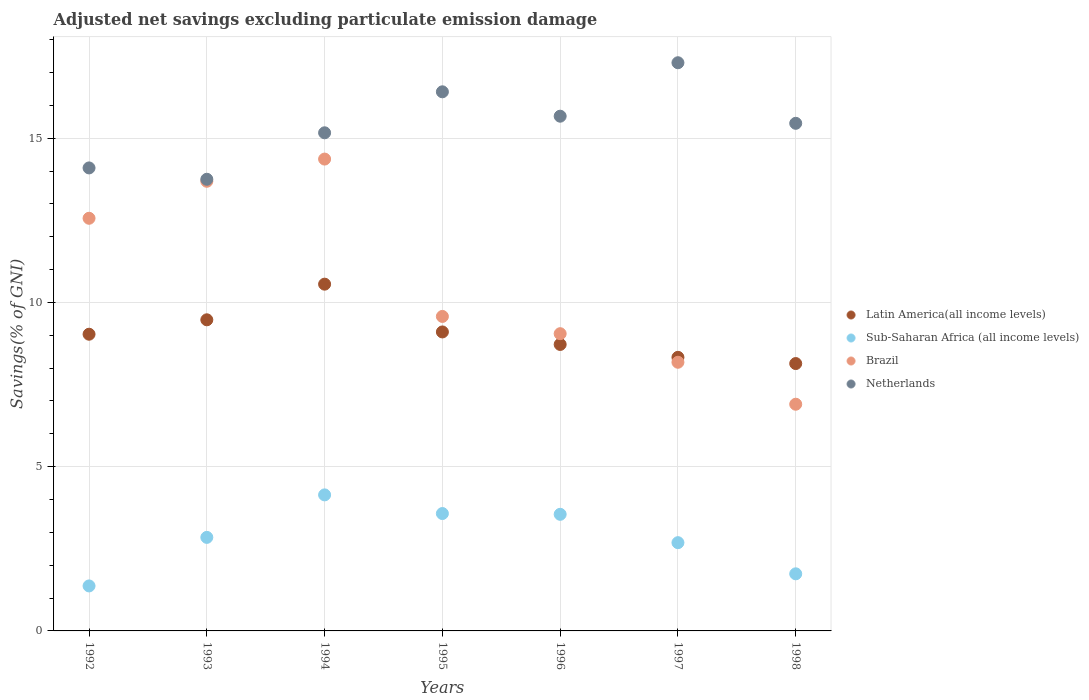How many different coloured dotlines are there?
Give a very brief answer. 4. Is the number of dotlines equal to the number of legend labels?
Provide a succinct answer. Yes. What is the adjusted net savings in Netherlands in 1998?
Your response must be concise. 15.45. Across all years, what is the maximum adjusted net savings in Sub-Saharan Africa (all income levels)?
Make the answer very short. 4.14. Across all years, what is the minimum adjusted net savings in Netherlands?
Your response must be concise. 13.75. In which year was the adjusted net savings in Netherlands minimum?
Make the answer very short. 1993. What is the total adjusted net savings in Sub-Saharan Africa (all income levels) in the graph?
Keep it short and to the point. 19.91. What is the difference between the adjusted net savings in Brazil in 1996 and that in 1997?
Provide a succinct answer. 0.87. What is the difference between the adjusted net savings in Latin America(all income levels) in 1994 and the adjusted net savings in Sub-Saharan Africa (all income levels) in 1996?
Provide a short and direct response. 7.01. What is the average adjusted net savings in Sub-Saharan Africa (all income levels) per year?
Provide a short and direct response. 2.84. In the year 1995, what is the difference between the adjusted net savings in Brazil and adjusted net savings in Netherlands?
Your response must be concise. -6.84. What is the ratio of the adjusted net savings in Brazil in 1993 to that in 1998?
Keep it short and to the point. 1.98. Is the difference between the adjusted net savings in Brazil in 1992 and 1993 greater than the difference between the adjusted net savings in Netherlands in 1992 and 1993?
Offer a very short reply. No. What is the difference between the highest and the second highest adjusted net savings in Sub-Saharan Africa (all income levels)?
Give a very brief answer. 0.57. What is the difference between the highest and the lowest adjusted net savings in Netherlands?
Offer a terse response. 3.55. In how many years, is the adjusted net savings in Latin America(all income levels) greater than the average adjusted net savings in Latin America(all income levels) taken over all years?
Ensure brevity in your answer.  3. Is the sum of the adjusted net savings in Netherlands in 1994 and 1998 greater than the maximum adjusted net savings in Latin America(all income levels) across all years?
Provide a short and direct response. Yes. Is it the case that in every year, the sum of the adjusted net savings in Latin America(all income levels) and adjusted net savings in Sub-Saharan Africa (all income levels)  is greater than the sum of adjusted net savings in Netherlands and adjusted net savings in Brazil?
Make the answer very short. No. Is the adjusted net savings in Netherlands strictly greater than the adjusted net savings in Brazil over the years?
Your answer should be compact. Yes. Is the adjusted net savings in Brazil strictly less than the adjusted net savings in Latin America(all income levels) over the years?
Your answer should be very brief. No. What is the difference between two consecutive major ticks on the Y-axis?
Make the answer very short. 5. Are the values on the major ticks of Y-axis written in scientific E-notation?
Your answer should be compact. No. Does the graph contain any zero values?
Make the answer very short. No. Where does the legend appear in the graph?
Provide a succinct answer. Center right. How are the legend labels stacked?
Your response must be concise. Vertical. What is the title of the graph?
Make the answer very short. Adjusted net savings excluding particulate emission damage. What is the label or title of the X-axis?
Keep it short and to the point. Years. What is the label or title of the Y-axis?
Offer a very short reply. Savings(% of GNI). What is the Savings(% of GNI) of Latin America(all income levels) in 1992?
Provide a succinct answer. 9.03. What is the Savings(% of GNI) in Sub-Saharan Africa (all income levels) in 1992?
Offer a terse response. 1.37. What is the Savings(% of GNI) in Brazil in 1992?
Your answer should be very brief. 12.56. What is the Savings(% of GNI) in Netherlands in 1992?
Your response must be concise. 14.09. What is the Savings(% of GNI) of Latin America(all income levels) in 1993?
Ensure brevity in your answer.  9.47. What is the Savings(% of GNI) in Sub-Saharan Africa (all income levels) in 1993?
Offer a terse response. 2.85. What is the Savings(% of GNI) in Brazil in 1993?
Provide a short and direct response. 13.69. What is the Savings(% of GNI) in Netherlands in 1993?
Your answer should be very brief. 13.75. What is the Savings(% of GNI) in Latin America(all income levels) in 1994?
Your answer should be compact. 10.56. What is the Savings(% of GNI) in Sub-Saharan Africa (all income levels) in 1994?
Keep it short and to the point. 4.14. What is the Savings(% of GNI) in Brazil in 1994?
Your response must be concise. 14.36. What is the Savings(% of GNI) in Netherlands in 1994?
Your answer should be compact. 15.16. What is the Savings(% of GNI) of Latin America(all income levels) in 1995?
Your answer should be compact. 9.1. What is the Savings(% of GNI) of Sub-Saharan Africa (all income levels) in 1995?
Provide a short and direct response. 3.57. What is the Savings(% of GNI) of Brazil in 1995?
Offer a very short reply. 9.57. What is the Savings(% of GNI) of Netherlands in 1995?
Offer a very short reply. 16.41. What is the Savings(% of GNI) in Latin America(all income levels) in 1996?
Offer a very short reply. 8.72. What is the Savings(% of GNI) in Sub-Saharan Africa (all income levels) in 1996?
Your answer should be compact. 3.55. What is the Savings(% of GNI) of Brazil in 1996?
Provide a short and direct response. 9.05. What is the Savings(% of GNI) of Netherlands in 1996?
Give a very brief answer. 15.67. What is the Savings(% of GNI) of Latin America(all income levels) in 1997?
Offer a terse response. 8.33. What is the Savings(% of GNI) of Sub-Saharan Africa (all income levels) in 1997?
Ensure brevity in your answer.  2.69. What is the Savings(% of GNI) in Brazil in 1997?
Your answer should be compact. 8.18. What is the Savings(% of GNI) in Netherlands in 1997?
Your answer should be compact. 17.3. What is the Savings(% of GNI) of Latin America(all income levels) in 1998?
Offer a very short reply. 8.14. What is the Savings(% of GNI) in Sub-Saharan Africa (all income levels) in 1998?
Keep it short and to the point. 1.74. What is the Savings(% of GNI) of Brazil in 1998?
Your response must be concise. 6.9. What is the Savings(% of GNI) of Netherlands in 1998?
Make the answer very short. 15.45. Across all years, what is the maximum Savings(% of GNI) of Latin America(all income levels)?
Your response must be concise. 10.56. Across all years, what is the maximum Savings(% of GNI) in Sub-Saharan Africa (all income levels)?
Keep it short and to the point. 4.14. Across all years, what is the maximum Savings(% of GNI) in Brazil?
Give a very brief answer. 14.36. Across all years, what is the maximum Savings(% of GNI) of Netherlands?
Offer a very short reply. 17.3. Across all years, what is the minimum Savings(% of GNI) of Latin America(all income levels)?
Your answer should be very brief. 8.14. Across all years, what is the minimum Savings(% of GNI) in Sub-Saharan Africa (all income levels)?
Provide a short and direct response. 1.37. Across all years, what is the minimum Savings(% of GNI) in Brazil?
Ensure brevity in your answer.  6.9. Across all years, what is the minimum Savings(% of GNI) of Netherlands?
Your response must be concise. 13.75. What is the total Savings(% of GNI) of Latin America(all income levels) in the graph?
Provide a short and direct response. 63.35. What is the total Savings(% of GNI) in Sub-Saharan Africa (all income levels) in the graph?
Ensure brevity in your answer.  19.91. What is the total Savings(% of GNI) in Brazil in the graph?
Provide a short and direct response. 74.31. What is the total Savings(% of GNI) in Netherlands in the graph?
Your response must be concise. 107.84. What is the difference between the Savings(% of GNI) of Latin America(all income levels) in 1992 and that in 1993?
Provide a short and direct response. -0.44. What is the difference between the Savings(% of GNI) of Sub-Saharan Africa (all income levels) in 1992 and that in 1993?
Your answer should be compact. -1.48. What is the difference between the Savings(% of GNI) in Brazil in 1992 and that in 1993?
Your response must be concise. -1.13. What is the difference between the Savings(% of GNI) of Netherlands in 1992 and that in 1993?
Keep it short and to the point. 0.35. What is the difference between the Savings(% of GNI) in Latin America(all income levels) in 1992 and that in 1994?
Offer a terse response. -1.52. What is the difference between the Savings(% of GNI) in Sub-Saharan Africa (all income levels) in 1992 and that in 1994?
Your answer should be very brief. -2.77. What is the difference between the Savings(% of GNI) of Brazil in 1992 and that in 1994?
Keep it short and to the point. -1.8. What is the difference between the Savings(% of GNI) of Netherlands in 1992 and that in 1994?
Your response must be concise. -1.07. What is the difference between the Savings(% of GNI) of Latin America(all income levels) in 1992 and that in 1995?
Give a very brief answer. -0.07. What is the difference between the Savings(% of GNI) in Sub-Saharan Africa (all income levels) in 1992 and that in 1995?
Keep it short and to the point. -2.2. What is the difference between the Savings(% of GNI) in Brazil in 1992 and that in 1995?
Provide a short and direct response. 2.99. What is the difference between the Savings(% of GNI) of Netherlands in 1992 and that in 1995?
Ensure brevity in your answer.  -2.32. What is the difference between the Savings(% of GNI) in Latin America(all income levels) in 1992 and that in 1996?
Your answer should be very brief. 0.31. What is the difference between the Savings(% of GNI) of Sub-Saharan Africa (all income levels) in 1992 and that in 1996?
Provide a succinct answer. -2.18. What is the difference between the Savings(% of GNI) in Brazil in 1992 and that in 1996?
Your answer should be very brief. 3.51. What is the difference between the Savings(% of GNI) of Netherlands in 1992 and that in 1996?
Provide a short and direct response. -1.57. What is the difference between the Savings(% of GNI) in Latin America(all income levels) in 1992 and that in 1997?
Offer a very short reply. 0.7. What is the difference between the Savings(% of GNI) of Sub-Saharan Africa (all income levels) in 1992 and that in 1997?
Ensure brevity in your answer.  -1.32. What is the difference between the Savings(% of GNI) in Brazil in 1992 and that in 1997?
Offer a terse response. 4.38. What is the difference between the Savings(% of GNI) in Netherlands in 1992 and that in 1997?
Offer a terse response. -3.2. What is the difference between the Savings(% of GNI) of Latin America(all income levels) in 1992 and that in 1998?
Make the answer very short. 0.89. What is the difference between the Savings(% of GNI) of Sub-Saharan Africa (all income levels) in 1992 and that in 1998?
Your response must be concise. -0.37. What is the difference between the Savings(% of GNI) in Brazil in 1992 and that in 1998?
Give a very brief answer. 5.66. What is the difference between the Savings(% of GNI) in Netherlands in 1992 and that in 1998?
Offer a terse response. -1.36. What is the difference between the Savings(% of GNI) of Latin America(all income levels) in 1993 and that in 1994?
Your answer should be very brief. -1.08. What is the difference between the Savings(% of GNI) in Sub-Saharan Africa (all income levels) in 1993 and that in 1994?
Your response must be concise. -1.29. What is the difference between the Savings(% of GNI) in Brazil in 1993 and that in 1994?
Your answer should be compact. -0.68. What is the difference between the Savings(% of GNI) in Netherlands in 1993 and that in 1994?
Give a very brief answer. -1.41. What is the difference between the Savings(% of GNI) of Latin America(all income levels) in 1993 and that in 1995?
Provide a short and direct response. 0.37. What is the difference between the Savings(% of GNI) of Sub-Saharan Africa (all income levels) in 1993 and that in 1995?
Keep it short and to the point. -0.73. What is the difference between the Savings(% of GNI) in Brazil in 1993 and that in 1995?
Offer a terse response. 4.11. What is the difference between the Savings(% of GNI) of Netherlands in 1993 and that in 1995?
Your response must be concise. -2.66. What is the difference between the Savings(% of GNI) of Latin America(all income levels) in 1993 and that in 1996?
Make the answer very short. 0.75. What is the difference between the Savings(% of GNI) of Sub-Saharan Africa (all income levels) in 1993 and that in 1996?
Make the answer very short. -0.7. What is the difference between the Savings(% of GNI) of Brazil in 1993 and that in 1996?
Your answer should be very brief. 4.64. What is the difference between the Savings(% of GNI) of Netherlands in 1993 and that in 1996?
Provide a succinct answer. -1.92. What is the difference between the Savings(% of GNI) of Latin America(all income levels) in 1993 and that in 1997?
Offer a terse response. 1.14. What is the difference between the Savings(% of GNI) in Sub-Saharan Africa (all income levels) in 1993 and that in 1997?
Offer a terse response. 0.16. What is the difference between the Savings(% of GNI) in Brazil in 1993 and that in 1997?
Give a very brief answer. 5.51. What is the difference between the Savings(% of GNI) of Netherlands in 1993 and that in 1997?
Your answer should be very brief. -3.55. What is the difference between the Savings(% of GNI) of Latin America(all income levels) in 1993 and that in 1998?
Keep it short and to the point. 1.33. What is the difference between the Savings(% of GNI) of Sub-Saharan Africa (all income levels) in 1993 and that in 1998?
Give a very brief answer. 1.11. What is the difference between the Savings(% of GNI) in Brazil in 1993 and that in 1998?
Keep it short and to the point. 6.79. What is the difference between the Savings(% of GNI) of Netherlands in 1993 and that in 1998?
Your answer should be very brief. -1.7. What is the difference between the Savings(% of GNI) of Latin America(all income levels) in 1994 and that in 1995?
Provide a short and direct response. 1.45. What is the difference between the Savings(% of GNI) in Sub-Saharan Africa (all income levels) in 1994 and that in 1995?
Provide a short and direct response. 0.57. What is the difference between the Savings(% of GNI) of Brazil in 1994 and that in 1995?
Provide a succinct answer. 4.79. What is the difference between the Savings(% of GNI) of Netherlands in 1994 and that in 1995?
Keep it short and to the point. -1.25. What is the difference between the Savings(% of GNI) of Latin America(all income levels) in 1994 and that in 1996?
Your response must be concise. 1.84. What is the difference between the Savings(% of GNI) in Sub-Saharan Africa (all income levels) in 1994 and that in 1996?
Your response must be concise. 0.59. What is the difference between the Savings(% of GNI) of Brazil in 1994 and that in 1996?
Give a very brief answer. 5.32. What is the difference between the Savings(% of GNI) in Netherlands in 1994 and that in 1996?
Provide a succinct answer. -0.51. What is the difference between the Savings(% of GNI) in Latin America(all income levels) in 1994 and that in 1997?
Your response must be concise. 2.23. What is the difference between the Savings(% of GNI) in Sub-Saharan Africa (all income levels) in 1994 and that in 1997?
Your response must be concise. 1.45. What is the difference between the Savings(% of GNI) in Brazil in 1994 and that in 1997?
Your answer should be compact. 6.19. What is the difference between the Savings(% of GNI) of Netherlands in 1994 and that in 1997?
Offer a very short reply. -2.13. What is the difference between the Savings(% of GNI) in Latin America(all income levels) in 1994 and that in 1998?
Offer a terse response. 2.42. What is the difference between the Savings(% of GNI) in Sub-Saharan Africa (all income levels) in 1994 and that in 1998?
Ensure brevity in your answer.  2.4. What is the difference between the Savings(% of GNI) of Brazil in 1994 and that in 1998?
Give a very brief answer. 7.46. What is the difference between the Savings(% of GNI) in Netherlands in 1994 and that in 1998?
Provide a succinct answer. -0.29. What is the difference between the Savings(% of GNI) in Latin America(all income levels) in 1995 and that in 1996?
Provide a succinct answer. 0.38. What is the difference between the Savings(% of GNI) in Sub-Saharan Africa (all income levels) in 1995 and that in 1996?
Give a very brief answer. 0.02. What is the difference between the Savings(% of GNI) in Brazil in 1995 and that in 1996?
Make the answer very short. 0.53. What is the difference between the Savings(% of GNI) in Netherlands in 1995 and that in 1996?
Keep it short and to the point. 0.74. What is the difference between the Savings(% of GNI) in Latin America(all income levels) in 1995 and that in 1997?
Give a very brief answer. 0.77. What is the difference between the Savings(% of GNI) in Sub-Saharan Africa (all income levels) in 1995 and that in 1997?
Your answer should be very brief. 0.89. What is the difference between the Savings(% of GNI) of Brazil in 1995 and that in 1997?
Offer a terse response. 1.4. What is the difference between the Savings(% of GNI) in Netherlands in 1995 and that in 1997?
Make the answer very short. -0.89. What is the difference between the Savings(% of GNI) of Latin America(all income levels) in 1995 and that in 1998?
Your response must be concise. 0.96. What is the difference between the Savings(% of GNI) of Sub-Saharan Africa (all income levels) in 1995 and that in 1998?
Your answer should be very brief. 1.83. What is the difference between the Savings(% of GNI) in Brazil in 1995 and that in 1998?
Make the answer very short. 2.67. What is the difference between the Savings(% of GNI) of Netherlands in 1995 and that in 1998?
Your answer should be compact. 0.96. What is the difference between the Savings(% of GNI) in Latin America(all income levels) in 1996 and that in 1997?
Provide a short and direct response. 0.39. What is the difference between the Savings(% of GNI) in Sub-Saharan Africa (all income levels) in 1996 and that in 1997?
Your response must be concise. 0.86. What is the difference between the Savings(% of GNI) of Brazil in 1996 and that in 1997?
Provide a succinct answer. 0.87. What is the difference between the Savings(% of GNI) in Netherlands in 1996 and that in 1997?
Make the answer very short. -1.63. What is the difference between the Savings(% of GNI) of Latin America(all income levels) in 1996 and that in 1998?
Offer a very short reply. 0.58. What is the difference between the Savings(% of GNI) of Sub-Saharan Africa (all income levels) in 1996 and that in 1998?
Offer a terse response. 1.81. What is the difference between the Savings(% of GNI) in Brazil in 1996 and that in 1998?
Provide a short and direct response. 2.15. What is the difference between the Savings(% of GNI) in Netherlands in 1996 and that in 1998?
Your answer should be compact. 0.22. What is the difference between the Savings(% of GNI) of Latin America(all income levels) in 1997 and that in 1998?
Keep it short and to the point. 0.19. What is the difference between the Savings(% of GNI) of Sub-Saharan Africa (all income levels) in 1997 and that in 1998?
Give a very brief answer. 0.95. What is the difference between the Savings(% of GNI) in Brazil in 1997 and that in 1998?
Your answer should be compact. 1.28. What is the difference between the Savings(% of GNI) in Netherlands in 1997 and that in 1998?
Give a very brief answer. 1.84. What is the difference between the Savings(% of GNI) of Latin America(all income levels) in 1992 and the Savings(% of GNI) of Sub-Saharan Africa (all income levels) in 1993?
Give a very brief answer. 6.18. What is the difference between the Savings(% of GNI) of Latin America(all income levels) in 1992 and the Savings(% of GNI) of Brazil in 1993?
Make the answer very short. -4.66. What is the difference between the Savings(% of GNI) of Latin America(all income levels) in 1992 and the Savings(% of GNI) of Netherlands in 1993?
Ensure brevity in your answer.  -4.72. What is the difference between the Savings(% of GNI) in Sub-Saharan Africa (all income levels) in 1992 and the Savings(% of GNI) in Brazil in 1993?
Provide a short and direct response. -12.32. What is the difference between the Savings(% of GNI) of Sub-Saharan Africa (all income levels) in 1992 and the Savings(% of GNI) of Netherlands in 1993?
Your answer should be compact. -12.38. What is the difference between the Savings(% of GNI) of Brazil in 1992 and the Savings(% of GNI) of Netherlands in 1993?
Make the answer very short. -1.19. What is the difference between the Savings(% of GNI) in Latin America(all income levels) in 1992 and the Savings(% of GNI) in Sub-Saharan Africa (all income levels) in 1994?
Provide a succinct answer. 4.89. What is the difference between the Savings(% of GNI) in Latin America(all income levels) in 1992 and the Savings(% of GNI) in Brazil in 1994?
Ensure brevity in your answer.  -5.33. What is the difference between the Savings(% of GNI) of Latin America(all income levels) in 1992 and the Savings(% of GNI) of Netherlands in 1994?
Make the answer very short. -6.13. What is the difference between the Savings(% of GNI) of Sub-Saharan Africa (all income levels) in 1992 and the Savings(% of GNI) of Brazil in 1994?
Offer a very short reply. -12.99. What is the difference between the Savings(% of GNI) of Sub-Saharan Africa (all income levels) in 1992 and the Savings(% of GNI) of Netherlands in 1994?
Provide a succinct answer. -13.79. What is the difference between the Savings(% of GNI) of Brazil in 1992 and the Savings(% of GNI) of Netherlands in 1994?
Offer a terse response. -2.6. What is the difference between the Savings(% of GNI) of Latin America(all income levels) in 1992 and the Savings(% of GNI) of Sub-Saharan Africa (all income levels) in 1995?
Provide a short and direct response. 5.46. What is the difference between the Savings(% of GNI) of Latin America(all income levels) in 1992 and the Savings(% of GNI) of Brazil in 1995?
Your response must be concise. -0.54. What is the difference between the Savings(% of GNI) in Latin America(all income levels) in 1992 and the Savings(% of GNI) in Netherlands in 1995?
Ensure brevity in your answer.  -7.38. What is the difference between the Savings(% of GNI) in Sub-Saharan Africa (all income levels) in 1992 and the Savings(% of GNI) in Brazil in 1995?
Offer a terse response. -8.2. What is the difference between the Savings(% of GNI) in Sub-Saharan Africa (all income levels) in 1992 and the Savings(% of GNI) in Netherlands in 1995?
Provide a succinct answer. -15.04. What is the difference between the Savings(% of GNI) in Brazil in 1992 and the Savings(% of GNI) in Netherlands in 1995?
Provide a short and direct response. -3.85. What is the difference between the Savings(% of GNI) in Latin America(all income levels) in 1992 and the Savings(% of GNI) in Sub-Saharan Africa (all income levels) in 1996?
Offer a very short reply. 5.48. What is the difference between the Savings(% of GNI) in Latin America(all income levels) in 1992 and the Savings(% of GNI) in Brazil in 1996?
Provide a succinct answer. -0.02. What is the difference between the Savings(% of GNI) in Latin America(all income levels) in 1992 and the Savings(% of GNI) in Netherlands in 1996?
Make the answer very short. -6.64. What is the difference between the Savings(% of GNI) of Sub-Saharan Africa (all income levels) in 1992 and the Savings(% of GNI) of Brazil in 1996?
Your response must be concise. -7.68. What is the difference between the Savings(% of GNI) of Sub-Saharan Africa (all income levels) in 1992 and the Savings(% of GNI) of Netherlands in 1996?
Keep it short and to the point. -14.3. What is the difference between the Savings(% of GNI) in Brazil in 1992 and the Savings(% of GNI) in Netherlands in 1996?
Give a very brief answer. -3.11. What is the difference between the Savings(% of GNI) in Latin America(all income levels) in 1992 and the Savings(% of GNI) in Sub-Saharan Africa (all income levels) in 1997?
Offer a terse response. 6.35. What is the difference between the Savings(% of GNI) in Latin America(all income levels) in 1992 and the Savings(% of GNI) in Brazil in 1997?
Provide a succinct answer. 0.85. What is the difference between the Savings(% of GNI) in Latin America(all income levels) in 1992 and the Savings(% of GNI) in Netherlands in 1997?
Make the answer very short. -8.26. What is the difference between the Savings(% of GNI) of Sub-Saharan Africa (all income levels) in 1992 and the Savings(% of GNI) of Brazil in 1997?
Offer a very short reply. -6.81. What is the difference between the Savings(% of GNI) of Sub-Saharan Africa (all income levels) in 1992 and the Savings(% of GNI) of Netherlands in 1997?
Keep it short and to the point. -15.93. What is the difference between the Savings(% of GNI) in Brazil in 1992 and the Savings(% of GNI) in Netherlands in 1997?
Your answer should be compact. -4.74. What is the difference between the Savings(% of GNI) in Latin America(all income levels) in 1992 and the Savings(% of GNI) in Sub-Saharan Africa (all income levels) in 1998?
Provide a short and direct response. 7.29. What is the difference between the Savings(% of GNI) in Latin America(all income levels) in 1992 and the Savings(% of GNI) in Brazil in 1998?
Keep it short and to the point. 2.13. What is the difference between the Savings(% of GNI) in Latin America(all income levels) in 1992 and the Savings(% of GNI) in Netherlands in 1998?
Provide a succinct answer. -6.42. What is the difference between the Savings(% of GNI) of Sub-Saharan Africa (all income levels) in 1992 and the Savings(% of GNI) of Brazil in 1998?
Offer a terse response. -5.53. What is the difference between the Savings(% of GNI) of Sub-Saharan Africa (all income levels) in 1992 and the Savings(% of GNI) of Netherlands in 1998?
Ensure brevity in your answer.  -14.08. What is the difference between the Savings(% of GNI) of Brazil in 1992 and the Savings(% of GNI) of Netherlands in 1998?
Your response must be concise. -2.89. What is the difference between the Savings(% of GNI) in Latin America(all income levels) in 1993 and the Savings(% of GNI) in Sub-Saharan Africa (all income levels) in 1994?
Your response must be concise. 5.33. What is the difference between the Savings(% of GNI) in Latin America(all income levels) in 1993 and the Savings(% of GNI) in Brazil in 1994?
Your answer should be compact. -4.89. What is the difference between the Savings(% of GNI) in Latin America(all income levels) in 1993 and the Savings(% of GNI) in Netherlands in 1994?
Keep it short and to the point. -5.69. What is the difference between the Savings(% of GNI) of Sub-Saharan Africa (all income levels) in 1993 and the Savings(% of GNI) of Brazil in 1994?
Provide a succinct answer. -11.52. What is the difference between the Savings(% of GNI) of Sub-Saharan Africa (all income levels) in 1993 and the Savings(% of GNI) of Netherlands in 1994?
Make the answer very short. -12.32. What is the difference between the Savings(% of GNI) in Brazil in 1993 and the Savings(% of GNI) in Netherlands in 1994?
Your answer should be compact. -1.48. What is the difference between the Savings(% of GNI) of Latin America(all income levels) in 1993 and the Savings(% of GNI) of Sub-Saharan Africa (all income levels) in 1995?
Provide a succinct answer. 5.9. What is the difference between the Savings(% of GNI) in Latin America(all income levels) in 1993 and the Savings(% of GNI) in Brazil in 1995?
Your answer should be very brief. -0.1. What is the difference between the Savings(% of GNI) of Latin America(all income levels) in 1993 and the Savings(% of GNI) of Netherlands in 1995?
Provide a succinct answer. -6.94. What is the difference between the Savings(% of GNI) of Sub-Saharan Africa (all income levels) in 1993 and the Savings(% of GNI) of Brazil in 1995?
Provide a short and direct response. -6.73. What is the difference between the Savings(% of GNI) of Sub-Saharan Africa (all income levels) in 1993 and the Savings(% of GNI) of Netherlands in 1995?
Offer a terse response. -13.56. What is the difference between the Savings(% of GNI) of Brazil in 1993 and the Savings(% of GNI) of Netherlands in 1995?
Offer a terse response. -2.72. What is the difference between the Savings(% of GNI) of Latin America(all income levels) in 1993 and the Savings(% of GNI) of Sub-Saharan Africa (all income levels) in 1996?
Give a very brief answer. 5.92. What is the difference between the Savings(% of GNI) in Latin America(all income levels) in 1993 and the Savings(% of GNI) in Brazil in 1996?
Provide a short and direct response. 0.42. What is the difference between the Savings(% of GNI) in Latin America(all income levels) in 1993 and the Savings(% of GNI) in Netherlands in 1996?
Give a very brief answer. -6.2. What is the difference between the Savings(% of GNI) in Sub-Saharan Africa (all income levels) in 1993 and the Savings(% of GNI) in Brazil in 1996?
Provide a short and direct response. -6.2. What is the difference between the Savings(% of GNI) in Sub-Saharan Africa (all income levels) in 1993 and the Savings(% of GNI) in Netherlands in 1996?
Provide a succinct answer. -12.82. What is the difference between the Savings(% of GNI) in Brazil in 1993 and the Savings(% of GNI) in Netherlands in 1996?
Offer a terse response. -1.98. What is the difference between the Savings(% of GNI) in Latin America(all income levels) in 1993 and the Savings(% of GNI) in Sub-Saharan Africa (all income levels) in 1997?
Your response must be concise. 6.78. What is the difference between the Savings(% of GNI) in Latin America(all income levels) in 1993 and the Savings(% of GNI) in Brazil in 1997?
Offer a terse response. 1.29. What is the difference between the Savings(% of GNI) of Latin America(all income levels) in 1993 and the Savings(% of GNI) of Netherlands in 1997?
Your answer should be very brief. -7.83. What is the difference between the Savings(% of GNI) of Sub-Saharan Africa (all income levels) in 1993 and the Savings(% of GNI) of Brazil in 1997?
Your answer should be very brief. -5.33. What is the difference between the Savings(% of GNI) of Sub-Saharan Africa (all income levels) in 1993 and the Savings(% of GNI) of Netherlands in 1997?
Ensure brevity in your answer.  -14.45. What is the difference between the Savings(% of GNI) in Brazil in 1993 and the Savings(% of GNI) in Netherlands in 1997?
Your answer should be very brief. -3.61. What is the difference between the Savings(% of GNI) in Latin America(all income levels) in 1993 and the Savings(% of GNI) in Sub-Saharan Africa (all income levels) in 1998?
Offer a terse response. 7.73. What is the difference between the Savings(% of GNI) in Latin America(all income levels) in 1993 and the Savings(% of GNI) in Brazil in 1998?
Ensure brevity in your answer.  2.57. What is the difference between the Savings(% of GNI) in Latin America(all income levels) in 1993 and the Savings(% of GNI) in Netherlands in 1998?
Ensure brevity in your answer.  -5.98. What is the difference between the Savings(% of GNI) in Sub-Saharan Africa (all income levels) in 1993 and the Savings(% of GNI) in Brazil in 1998?
Offer a very short reply. -4.05. What is the difference between the Savings(% of GNI) of Sub-Saharan Africa (all income levels) in 1993 and the Savings(% of GNI) of Netherlands in 1998?
Your answer should be very brief. -12.61. What is the difference between the Savings(% of GNI) in Brazil in 1993 and the Savings(% of GNI) in Netherlands in 1998?
Offer a very short reply. -1.76. What is the difference between the Savings(% of GNI) of Latin America(all income levels) in 1994 and the Savings(% of GNI) of Sub-Saharan Africa (all income levels) in 1995?
Offer a very short reply. 6.98. What is the difference between the Savings(% of GNI) of Latin America(all income levels) in 1994 and the Savings(% of GNI) of Brazil in 1995?
Give a very brief answer. 0.98. What is the difference between the Savings(% of GNI) of Latin America(all income levels) in 1994 and the Savings(% of GNI) of Netherlands in 1995?
Offer a terse response. -5.86. What is the difference between the Savings(% of GNI) in Sub-Saharan Africa (all income levels) in 1994 and the Savings(% of GNI) in Brazil in 1995?
Your response must be concise. -5.43. What is the difference between the Savings(% of GNI) of Sub-Saharan Africa (all income levels) in 1994 and the Savings(% of GNI) of Netherlands in 1995?
Your response must be concise. -12.27. What is the difference between the Savings(% of GNI) in Brazil in 1994 and the Savings(% of GNI) in Netherlands in 1995?
Your answer should be compact. -2.05. What is the difference between the Savings(% of GNI) in Latin America(all income levels) in 1994 and the Savings(% of GNI) in Sub-Saharan Africa (all income levels) in 1996?
Offer a terse response. 7.01. What is the difference between the Savings(% of GNI) of Latin America(all income levels) in 1994 and the Savings(% of GNI) of Brazil in 1996?
Keep it short and to the point. 1.51. What is the difference between the Savings(% of GNI) of Latin America(all income levels) in 1994 and the Savings(% of GNI) of Netherlands in 1996?
Your answer should be compact. -5.11. What is the difference between the Savings(% of GNI) of Sub-Saharan Africa (all income levels) in 1994 and the Savings(% of GNI) of Brazil in 1996?
Your response must be concise. -4.91. What is the difference between the Savings(% of GNI) of Sub-Saharan Africa (all income levels) in 1994 and the Savings(% of GNI) of Netherlands in 1996?
Offer a terse response. -11.53. What is the difference between the Savings(% of GNI) in Brazil in 1994 and the Savings(% of GNI) in Netherlands in 1996?
Your response must be concise. -1.31. What is the difference between the Savings(% of GNI) in Latin America(all income levels) in 1994 and the Savings(% of GNI) in Sub-Saharan Africa (all income levels) in 1997?
Your answer should be very brief. 7.87. What is the difference between the Savings(% of GNI) of Latin America(all income levels) in 1994 and the Savings(% of GNI) of Brazil in 1997?
Offer a very short reply. 2.38. What is the difference between the Savings(% of GNI) of Latin America(all income levels) in 1994 and the Savings(% of GNI) of Netherlands in 1997?
Make the answer very short. -6.74. What is the difference between the Savings(% of GNI) of Sub-Saharan Africa (all income levels) in 1994 and the Savings(% of GNI) of Brazil in 1997?
Your answer should be compact. -4.04. What is the difference between the Savings(% of GNI) in Sub-Saharan Africa (all income levels) in 1994 and the Savings(% of GNI) in Netherlands in 1997?
Offer a very short reply. -13.16. What is the difference between the Savings(% of GNI) in Brazil in 1994 and the Savings(% of GNI) in Netherlands in 1997?
Make the answer very short. -2.93. What is the difference between the Savings(% of GNI) in Latin America(all income levels) in 1994 and the Savings(% of GNI) in Sub-Saharan Africa (all income levels) in 1998?
Give a very brief answer. 8.82. What is the difference between the Savings(% of GNI) of Latin America(all income levels) in 1994 and the Savings(% of GNI) of Brazil in 1998?
Offer a very short reply. 3.65. What is the difference between the Savings(% of GNI) in Latin America(all income levels) in 1994 and the Savings(% of GNI) in Netherlands in 1998?
Your response must be concise. -4.9. What is the difference between the Savings(% of GNI) in Sub-Saharan Africa (all income levels) in 1994 and the Savings(% of GNI) in Brazil in 1998?
Give a very brief answer. -2.76. What is the difference between the Savings(% of GNI) in Sub-Saharan Africa (all income levels) in 1994 and the Savings(% of GNI) in Netherlands in 1998?
Make the answer very short. -11.31. What is the difference between the Savings(% of GNI) of Brazil in 1994 and the Savings(% of GNI) of Netherlands in 1998?
Ensure brevity in your answer.  -1.09. What is the difference between the Savings(% of GNI) in Latin America(all income levels) in 1995 and the Savings(% of GNI) in Sub-Saharan Africa (all income levels) in 1996?
Offer a terse response. 5.55. What is the difference between the Savings(% of GNI) of Latin America(all income levels) in 1995 and the Savings(% of GNI) of Brazil in 1996?
Make the answer very short. 0.05. What is the difference between the Savings(% of GNI) of Latin America(all income levels) in 1995 and the Savings(% of GNI) of Netherlands in 1996?
Your response must be concise. -6.57. What is the difference between the Savings(% of GNI) of Sub-Saharan Africa (all income levels) in 1995 and the Savings(% of GNI) of Brazil in 1996?
Your response must be concise. -5.48. What is the difference between the Savings(% of GNI) in Sub-Saharan Africa (all income levels) in 1995 and the Savings(% of GNI) in Netherlands in 1996?
Provide a succinct answer. -12.1. What is the difference between the Savings(% of GNI) of Brazil in 1995 and the Savings(% of GNI) of Netherlands in 1996?
Provide a short and direct response. -6.1. What is the difference between the Savings(% of GNI) in Latin America(all income levels) in 1995 and the Savings(% of GNI) in Sub-Saharan Africa (all income levels) in 1997?
Give a very brief answer. 6.41. What is the difference between the Savings(% of GNI) of Latin America(all income levels) in 1995 and the Savings(% of GNI) of Brazil in 1997?
Make the answer very short. 0.92. What is the difference between the Savings(% of GNI) in Latin America(all income levels) in 1995 and the Savings(% of GNI) in Netherlands in 1997?
Ensure brevity in your answer.  -8.2. What is the difference between the Savings(% of GNI) in Sub-Saharan Africa (all income levels) in 1995 and the Savings(% of GNI) in Brazil in 1997?
Give a very brief answer. -4.61. What is the difference between the Savings(% of GNI) in Sub-Saharan Africa (all income levels) in 1995 and the Savings(% of GNI) in Netherlands in 1997?
Provide a short and direct response. -13.72. What is the difference between the Savings(% of GNI) in Brazil in 1995 and the Savings(% of GNI) in Netherlands in 1997?
Give a very brief answer. -7.72. What is the difference between the Savings(% of GNI) of Latin America(all income levels) in 1995 and the Savings(% of GNI) of Sub-Saharan Africa (all income levels) in 1998?
Offer a terse response. 7.36. What is the difference between the Savings(% of GNI) of Latin America(all income levels) in 1995 and the Savings(% of GNI) of Brazil in 1998?
Your answer should be very brief. 2.2. What is the difference between the Savings(% of GNI) in Latin America(all income levels) in 1995 and the Savings(% of GNI) in Netherlands in 1998?
Give a very brief answer. -6.35. What is the difference between the Savings(% of GNI) in Sub-Saharan Africa (all income levels) in 1995 and the Savings(% of GNI) in Brazil in 1998?
Your response must be concise. -3.33. What is the difference between the Savings(% of GNI) in Sub-Saharan Africa (all income levels) in 1995 and the Savings(% of GNI) in Netherlands in 1998?
Provide a succinct answer. -11.88. What is the difference between the Savings(% of GNI) in Brazil in 1995 and the Savings(% of GNI) in Netherlands in 1998?
Your response must be concise. -5.88. What is the difference between the Savings(% of GNI) of Latin America(all income levels) in 1996 and the Savings(% of GNI) of Sub-Saharan Africa (all income levels) in 1997?
Give a very brief answer. 6.03. What is the difference between the Savings(% of GNI) of Latin America(all income levels) in 1996 and the Savings(% of GNI) of Brazil in 1997?
Your answer should be compact. 0.54. What is the difference between the Savings(% of GNI) in Latin America(all income levels) in 1996 and the Savings(% of GNI) in Netherlands in 1997?
Provide a succinct answer. -8.58. What is the difference between the Savings(% of GNI) of Sub-Saharan Africa (all income levels) in 1996 and the Savings(% of GNI) of Brazil in 1997?
Give a very brief answer. -4.63. What is the difference between the Savings(% of GNI) in Sub-Saharan Africa (all income levels) in 1996 and the Savings(% of GNI) in Netherlands in 1997?
Make the answer very short. -13.75. What is the difference between the Savings(% of GNI) in Brazil in 1996 and the Savings(% of GNI) in Netherlands in 1997?
Your answer should be compact. -8.25. What is the difference between the Savings(% of GNI) of Latin America(all income levels) in 1996 and the Savings(% of GNI) of Sub-Saharan Africa (all income levels) in 1998?
Ensure brevity in your answer.  6.98. What is the difference between the Savings(% of GNI) of Latin America(all income levels) in 1996 and the Savings(% of GNI) of Brazil in 1998?
Provide a short and direct response. 1.82. What is the difference between the Savings(% of GNI) in Latin America(all income levels) in 1996 and the Savings(% of GNI) in Netherlands in 1998?
Keep it short and to the point. -6.73. What is the difference between the Savings(% of GNI) in Sub-Saharan Africa (all income levels) in 1996 and the Savings(% of GNI) in Brazil in 1998?
Provide a short and direct response. -3.35. What is the difference between the Savings(% of GNI) in Sub-Saharan Africa (all income levels) in 1996 and the Savings(% of GNI) in Netherlands in 1998?
Offer a terse response. -11.9. What is the difference between the Savings(% of GNI) in Brazil in 1996 and the Savings(% of GNI) in Netherlands in 1998?
Offer a terse response. -6.4. What is the difference between the Savings(% of GNI) in Latin America(all income levels) in 1997 and the Savings(% of GNI) in Sub-Saharan Africa (all income levels) in 1998?
Your response must be concise. 6.59. What is the difference between the Savings(% of GNI) in Latin America(all income levels) in 1997 and the Savings(% of GNI) in Brazil in 1998?
Give a very brief answer. 1.43. What is the difference between the Savings(% of GNI) in Latin America(all income levels) in 1997 and the Savings(% of GNI) in Netherlands in 1998?
Provide a short and direct response. -7.12. What is the difference between the Savings(% of GNI) in Sub-Saharan Africa (all income levels) in 1997 and the Savings(% of GNI) in Brazil in 1998?
Your answer should be compact. -4.21. What is the difference between the Savings(% of GNI) in Sub-Saharan Africa (all income levels) in 1997 and the Savings(% of GNI) in Netherlands in 1998?
Your answer should be compact. -12.77. What is the difference between the Savings(% of GNI) in Brazil in 1997 and the Savings(% of GNI) in Netherlands in 1998?
Your answer should be compact. -7.27. What is the average Savings(% of GNI) in Latin America(all income levels) per year?
Your answer should be compact. 9.05. What is the average Savings(% of GNI) of Sub-Saharan Africa (all income levels) per year?
Your answer should be compact. 2.84. What is the average Savings(% of GNI) in Brazil per year?
Ensure brevity in your answer.  10.62. What is the average Savings(% of GNI) of Netherlands per year?
Offer a terse response. 15.41. In the year 1992, what is the difference between the Savings(% of GNI) in Latin America(all income levels) and Savings(% of GNI) in Sub-Saharan Africa (all income levels)?
Ensure brevity in your answer.  7.66. In the year 1992, what is the difference between the Savings(% of GNI) in Latin America(all income levels) and Savings(% of GNI) in Brazil?
Your answer should be very brief. -3.53. In the year 1992, what is the difference between the Savings(% of GNI) in Latin America(all income levels) and Savings(% of GNI) in Netherlands?
Your response must be concise. -5.06. In the year 1992, what is the difference between the Savings(% of GNI) of Sub-Saharan Africa (all income levels) and Savings(% of GNI) of Brazil?
Offer a very short reply. -11.19. In the year 1992, what is the difference between the Savings(% of GNI) in Sub-Saharan Africa (all income levels) and Savings(% of GNI) in Netherlands?
Your answer should be compact. -12.72. In the year 1992, what is the difference between the Savings(% of GNI) of Brazil and Savings(% of GNI) of Netherlands?
Offer a terse response. -1.53. In the year 1993, what is the difference between the Savings(% of GNI) of Latin America(all income levels) and Savings(% of GNI) of Sub-Saharan Africa (all income levels)?
Your answer should be compact. 6.62. In the year 1993, what is the difference between the Savings(% of GNI) in Latin America(all income levels) and Savings(% of GNI) in Brazil?
Your response must be concise. -4.22. In the year 1993, what is the difference between the Savings(% of GNI) in Latin America(all income levels) and Savings(% of GNI) in Netherlands?
Provide a succinct answer. -4.28. In the year 1993, what is the difference between the Savings(% of GNI) of Sub-Saharan Africa (all income levels) and Savings(% of GNI) of Brazil?
Ensure brevity in your answer.  -10.84. In the year 1993, what is the difference between the Savings(% of GNI) of Sub-Saharan Africa (all income levels) and Savings(% of GNI) of Netherlands?
Offer a terse response. -10.9. In the year 1993, what is the difference between the Savings(% of GNI) in Brazil and Savings(% of GNI) in Netherlands?
Your answer should be very brief. -0.06. In the year 1994, what is the difference between the Savings(% of GNI) of Latin America(all income levels) and Savings(% of GNI) of Sub-Saharan Africa (all income levels)?
Your answer should be compact. 6.41. In the year 1994, what is the difference between the Savings(% of GNI) in Latin America(all income levels) and Savings(% of GNI) in Brazil?
Your answer should be very brief. -3.81. In the year 1994, what is the difference between the Savings(% of GNI) in Latin America(all income levels) and Savings(% of GNI) in Netherlands?
Keep it short and to the point. -4.61. In the year 1994, what is the difference between the Savings(% of GNI) in Sub-Saharan Africa (all income levels) and Savings(% of GNI) in Brazil?
Offer a terse response. -10.22. In the year 1994, what is the difference between the Savings(% of GNI) in Sub-Saharan Africa (all income levels) and Savings(% of GNI) in Netherlands?
Provide a short and direct response. -11.02. In the year 1994, what is the difference between the Savings(% of GNI) in Brazil and Savings(% of GNI) in Netherlands?
Make the answer very short. -0.8. In the year 1995, what is the difference between the Savings(% of GNI) of Latin America(all income levels) and Savings(% of GNI) of Sub-Saharan Africa (all income levels)?
Provide a succinct answer. 5.53. In the year 1995, what is the difference between the Savings(% of GNI) in Latin America(all income levels) and Savings(% of GNI) in Brazil?
Keep it short and to the point. -0.47. In the year 1995, what is the difference between the Savings(% of GNI) of Latin America(all income levels) and Savings(% of GNI) of Netherlands?
Your answer should be very brief. -7.31. In the year 1995, what is the difference between the Savings(% of GNI) in Sub-Saharan Africa (all income levels) and Savings(% of GNI) in Brazil?
Your answer should be compact. -6. In the year 1995, what is the difference between the Savings(% of GNI) of Sub-Saharan Africa (all income levels) and Savings(% of GNI) of Netherlands?
Your answer should be compact. -12.84. In the year 1995, what is the difference between the Savings(% of GNI) in Brazil and Savings(% of GNI) in Netherlands?
Ensure brevity in your answer.  -6.84. In the year 1996, what is the difference between the Savings(% of GNI) of Latin America(all income levels) and Savings(% of GNI) of Sub-Saharan Africa (all income levels)?
Make the answer very short. 5.17. In the year 1996, what is the difference between the Savings(% of GNI) of Latin America(all income levels) and Savings(% of GNI) of Brazil?
Offer a very short reply. -0.33. In the year 1996, what is the difference between the Savings(% of GNI) of Latin America(all income levels) and Savings(% of GNI) of Netherlands?
Your response must be concise. -6.95. In the year 1996, what is the difference between the Savings(% of GNI) of Sub-Saharan Africa (all income levels) and Savings(% of GNI) of Brazil?
Your response must be concise. -5.5. In the year 1996, what is the difference between the Savings(% of GNI) in Sub-Saharan Africa (all income levels) and Savings(% of GNI) in Netherlands?
Ensure brevity in your answer.  -12.12. In the year 1996, what is the difference between the Savings(% of GNI) in Brazil and Savings(% of GNI) in Netherlands?
Ensure brevity in your answer.  -6.62. In the year 1997, what is the difference between the Savings(% of GNI) of Latin America(all income levels) and Savings(% of GNI) of Sub-Saharan Africa (all income levels)?
Provide a succinct answer. 5.64. In the year 1997, what is the difference between the Savings(% of GNI) in Latin America(all income levels) and Savings(% of GNI) in Brazil?
Provide a short and direct response. 0.15. In the year 1997, what is the difference between the Savings(% of GNI) of Latin America(all income levels) and Savings(% of GNI) of Netherlands?
Keep it short and to the point. -8.97. In the year 1997, what is the difference between the Savings(% of GNI) in Sub-Saharan Africa (all income levels) and Savings(% of GNI) in Brazil?
Your response must be concise. -5.49. In the year 1997, what is the difference between the Savings(% of GNI) in Sub-Saharan Africa (all income levels) and Savings(% of GNI) in Netherlands?
Provide a succinct answer. -14.61. In the year 1997, what is the difference between the Savings(% of GNI) of Brazil and Savings(% of GNI) of Netherlands?
Ensure brevity in your answer.  -9.12. In the year 1998, what is the difference between the Savings(% of GNI) of Latin America(all income levels) and Savings(% of GNI) of Sub-Saharan Africa (all income levels)?
Ensure brevity in your answer.  6.4. In the year 1998, what is the difference between the Savings(% of GNI) of Latin America(all income levels) and Savings(% of GNI) of Brazil?
Provide a short and direct response. 1.24. In the year 1998, what is the difference between the Savings(% of GNI) of Latin America(all income levels) and Savings(% of GNI) of Netherlands?
Your answer should be very brief. -7.31. In the year 1998, what is the difference between the Savings(% of GNI) in Sub-Saharan Africa (all income levels) and Savings(% of GNI) in Brazil?
Provide a succinct answer. -5.16. In the year 1998, what is the difference between the Savings(% of GNI) in Sub-Saharan Africa (all income levels) and Savings(% of GNI) in Netherlands?
Your response must be concise. -13.71. In the year 1998, what is the difference between the Savings(% of GNI) of Brazil and Savings(% of GNI) of Netherlands?
Keep it short and to the point. -8.55. What is the ratio of the Savings(% of GNI) of Latin America(all income levels) in 1992 to that in 1993?
Provide a succinct answer. 0.95. What is the ratio of the Savings(% of GNI) in Sub-Saharan Africa (all income levels) in 1992 to that in 1993?
Make the answer very short. 0.48. What is the ratio of the Savings(% of GNI) in Brazil in 1992 to that in 1993?
Offer a very short reply. 0.92. What is the ratio of the Savings(% of GNI) in Netherlands in 1992 to that in 1993?
Your answer should be very brief. 1.03. What is the ratio of the Savings(% of GNI) in Latin America(all income levels) in 1992 to that in 1994?
Offer a very short reply. 0.86. What is the ratio of the Savings(% of GNI) in Sub-Saharan Africa (all income levels) in 1992 to that in 1994?
Provide a succinct answer. 0.33. What is the ratio of the Savings(% of GNI) in Brazil in 1992 to that in 1994?
Your response must be concise. 0.87. What is the ratio of the Savings(% of GNI) of Netherlands in 1992 to that in 1994?
Ensure brevity in your answer.  0.93. What is the ratio of the Savings(% of GNI) in Latin America(all income levels) in 1992 to that in 1995?
Make the answer very short. 0.99. What is the ratio of the Savings(% of GNI) of Sub-Saharan Africa (all income levels) in 1992 to that in 1995?
Provide a succinct answer. 0.38. What is the ratio of the Savings(% of GNI) in Brazil in 1992 to that in 1995?
Your answer should be compact. 1.31. What is the ratio of the Savings(% of GNI) of Netherlands in 1992 to that in 1995?
Offer a terse response. 0.86. What is the ratio of the Savings(% of GNI) of Latin America(all income levels) in 1992 to that in 1996?
Give a very brief answer. 1.04. What is the ratio of the Savings(% of GNI) of Sub-Saharan Africa (all income levels) in 1992 to that in 1996?
Your response must be concise. 0.39. What is the ratio of the Savings(% of GNI) in Brazil in 1992 to that in 1996?
Your answer should be very brief. 1.39. What is the ratio of the Savings(% of GNI) of Netherlands in 1992 to that in 1996?
Keep it short and to the point. 0.9. What is the ratio of the Savings(% of GNI) in Latin America(all income levels) in 1992 to that in 1997?
Your answer should be very brief. 1.08. What is the ratio of the Savings(% of GNI) in Sub-Saharan Africa (all income levels) in 1992 to that in 1997?
Offer a terse response. 0.51. What is the ratio of the Savings(% of GNI) in Brazil in 1992 to that in 1997?
Keep it short and to the point. 1.54. What is the ratio of the Savings(% of GNI) in Netherlands in 1992 to that in 1997?
Provide a succinct answer. 0.81. What is the ratio of the Savings(% of GNI) in Latin America(all income levels) in 1992 to that in 1998?
Offer a terse response. 1.11. What is the ratio of the Savings(% of GNI) in Sub-Saharan Africa (all income levels) in 1992 to that in 1998?
Provide a succinct answer. 0.79. What is the ratio of the Savings(% of GNI) of Brazil in 1992 to that in 1998?
Ensure brevity in your answer.  1.82. What is the ratio of the Savings(% of GNI) of Netherlands in 1992 to that in 1998?
Provide a short and direct response. 0.91. What is the ratio of the Savings(% of GNI) of Latin America(all income levels) in 1993 to that in 1994?
Your response must be concise. 0.9. What is the ratio of the Savings(% of GNI) of Sub-Saharan Africa (all income levels) in 1993 to that in 1994?
Offer a terse response. 0.69. What is the ratio of the Savings(% of GNI) of Brazil in 1993 to that in 1994?
Your answer should be compact. 0.95. What is the ratio of the Savings(% of GNI) of Netherlands in 1993 to that in 1994?
Provide a short and direct response. 0.91. What is the ratio of the Savings(% of GNI) of Latin America(all income levels) in 1993 to that in 1995?
Offer a very short reply. 1.04. What is the ratio of the Savings(% of GNI) in Sub-Saharan Africa (all income levels) in 1993 to that in 1995?
Provide a succinct answer. 0.8. What is the ratio of the Savings(% of GNI) of Brazil in 1993 to that in 1995?
Provide a short and direct response. 1.43. What is the ratio of the Savings(% of GNI) of Netherlands in 1993 to that in 1995?
Make the answer very short. 0.84. What is the ratio of the Savings(% of GNI) of Latin America(all income levels) in 1993 to that in 1996?
Provide a short and direct response. 1.09. What is the ratio of the Savings(% of GNI) of Sub-Saharan Africa (all income levels) in 1993 to that in 1996?
Ensure brevity in your answer.  0.8. What is the ratio of the Savings(% of GNI) of Brazil in 1993 to that in 1996?
Give a very brief answer. 1.51. What is the ratio of the Savings(% of GNI) in Netherlands in 1993 to that in 1996?
Ensure brevity in your answer.  0.88. What is the ratio of the Savings(% of GNI) of Latin America(all income levels) in 1993 to that in 1997?
Your answer should be compact. 1.14. What is the ratio of the Savings(% of GNI) in Sub-Saharan Africa (all income levels) in 1993 to that in 1997?
Keep it short and to the point. 1.06. What is the ratio of the Savings(% of GNI) in Brazil in 1993 to that in 1997?
Offer a very short reply. 1.67. What is the ratio of the Savings(% of GNI) in Netherlands in 1993 to that in 1997?
Provide a succinct answer. 0.79. What is the ratio of the Savings(% of GNI) of Latin America(all income levels) in 1993 to that in 1998?
Your answer should be very brief. 1.16. What is the ratio of the Savings(% of GNI) in Sub-Saharan Africa (all income levels) in 1993 to that in 1998?
Your answer should be very brief. 1.64. What is the ratio of the Savings(% of GNI) in Brazil in 1993 to that in 1998?
Offer a terse response. 1.98. What is the ratio of the Savings(% of GNI) in Netherlands in 1993 to that in 1998?
Give a very brief answer. 0.89. What is the ratio of the Savings(% of GNI) of Latin America(all income levels) in 1994 to that in 1995?
Provide a short and direct response. 1.16. What is the ratio of the Savings(% of GNI) in Sub-Saharan Africa (all income levels) in 1994 to that in 1995?
Offer a terse response. 1.16. What is the ratio of the Savings(% of GNI) in Brazil in 1994 to that in 1995?
Offer a very short reply. 1.5. What is the ratio of the Savings(% of GNI) of Netherlands in 1994 to that in 1995?
Offer a terse response. 0.92. What is the ratio of the Savings(% of GNI) in Latin America(all income levels) in 1994 to that in 1996?
Give a very brief answer. 1.21. What is the ratio of the Savings(% of GNI) of Sub-Saharan Africa (all income levels) in 1994 to that in 1996?
Provide a succinct answer. 1.17. What is the ratio of the Savings(% of GNI) of Brazil in 1994 to that in 1996?
Give a very brief answer. 1.59. What is the ratio of the Savings(% of GNI) of Latin America(all income levels) in 1994 to that in 1997?
Provide a succinct answer. 1.27. What is the ratio of the Savings(% of GNI) of Sub-Saharan Africa (all income levels) in 1994 to that in 1997?
Your response must be concise. 1.54. What is the ratio of the Savings(% of GNI) of Brazil in 1994 to that in 1997?
Offer a very short reply. 1.76. What is the ratio of the Savings(% of GNI) in Netherlands in 1994 to that in 1997?
Offer a very short reply. 0.88. What is the ratio of the Savings(% of GNI) of Latin America(all income levels) in 1994 to that in 1998?
Ensure brevity in your answer.  1.3. What is the ratio of the Savings(% of GNI) in Sub-Saharan Africa (all income levels) in 1994 to that in 1998?
Offer a terse response. 2.38. What is the ratio of the Savings(% of GNI) in Brazil in 1994 to that in 1998?
Your answer should be compact. 2.08. What is the ratio of the Savings(% of GNI) of Netherlands in 1994 to that in 1998?
Keep it short and to the point. 0.98. What is the ratio of the Savings(% of GNI) of Latin America(all income levels) in 1995 to that in 1996?
Provide a succinct answer. 1.04. What is the ratio of the Savings(% of GNI) in Sub-Saharan Africa (all income levels) in 1995 to that in 1996?
Make the answer very short. 1.01. What is the ratio of the Savings(% of GNI) of Brazil in 1995 to that in 1996?
Provide a succinct answer. 1.06. What is the ratio of the Savings(% of GNI) of Netherlands in 1995 to that in 1996?
Provide a short and direct response. 1.05. What is the ratio of the Savings(% of GNI) of Latin America(all income levels) in 1995 to that in 1997?
Offer a very short reply. 1.09. What is the ratio of the Savings(% of GNI) in Sub-Saharan Africa (all income levels) in 1995 to that in 1997?
Your answer should be very brief. 1.33. What is the ratio of the Savings(% of GNI) of Brazil in 1995 to that in 1997?
Your answer should be compact. 1.17. What is the ratio of the Savings(% of GNI) in Netherlands in 1995 to that in 1997?
Make the answer very short. 0.95. What is the ratio of the Savings(% of GNI) in Latin America(all income levels) in 1995 to that in 1998?
Make the answer very short. 1.12. What is the ratio of the Savings(% of GNI) in Sub-Saharan Africa (all income levels) in 1995 to that in 1998?
Keep it short and to the point. 2.06. What is the ratio of the Savings(% of GNI) of Brazil in 1995 to that in 1998?
Your answer should be compact. 1.39. What is the ratio of the Savings(% of GNI) of Netherlands in 1995 to that in 1998?
Your response must be concise. 1.06. What is the ratio of the Savings(% of GNI) in Latin America(all income levels) in 1996 to that in 1997?
Your response must be concise. 1.05. What is the ratio of the Savings(% of GNI) of Sub-Saharan Africa (all income levels) in 1996 to that in 1997?
Provide a short and direct response. 1.32. What is the ratio of the Savings(% of GNI) of Brazil in 1996 to that in 1997?
Make the answer very short. 1.11. What is the ratio of the Savings(% of GNI) of Netherlands in 1996 to that in 1997?
Keep it short and to the point. 0.91. What is the ratio of the Savings(% of GNI) in Latin America(all income levels) in 1996 to that in 1998?
Make the answer very short. 1.07. What is the ratio of the Savings(% of GNI) in Sub-Saharan Africa (all income levels) in 1996 to that in 1998?
Your answer should be very brief. 2.04. What is the ratio of the Savings(% of GNI) in Brazil in 1996 to that in 1998?
Provide a short and direct response. 1.31. What is the ratio of the Savings(% of GNI) in Netherlands in 1996 to that in 1998?
Your response must be concise. 1.01. What is the ratio of the Savings(% of GNI) in Latin America(all income levels) in 1997 to that in 1998?
Make the answer very short. 1.02. What is the ratio of the Savings(% of GNI) of Sub-Saharan Africa (all income levels) in 1997 to that in 1998?
Your answer should be compact. 1.55. What is the ratio of the Savings(% of GNI) in Brazil in 1997 to that in 1998?
Offer a terse response. 1.19. What is the ratio of the Savings(% of GNI) of Netherlands in 1997 to that in 1998?
Your answer should be compact. 1.12. What is the difference between the highest and the second highest Savings(% of GNI) in Latin America(all income levels)?
Your answer should be compact. 1.08. What is the difference between the highest and the second highest Savings(% of GNI) in Sub-Saharan Africa (all income levels)?
Your answer should be compact. 0.57. What is the difference between the highest and the second highest Savings(% of GNI) of Brazil?
Ensure brevity in your answer.  0.68. What is the difference between the highest and the second highest Savings(% of GNI) in Netherlands?
Offer a terse response. 0.89. What is the difference between the highest and the lowest Savings(% of GNI) in Latin America(all income levels)?
Offer a very short reply. 2.42. What is the difference between the highest and the lowest Savings(% of GNI) in Sub-Saharan Africa (all income levels)?
Make the answer very short. 2.77. What is the difference between the highest and the lowest Savings(% of GNI) of Brazil?
Give a very brief answer. 7.46. What is the difference between the highest and the lowest Savings(% of GNI) in Netherlands?
Keep it short and to the point. 3.55. 